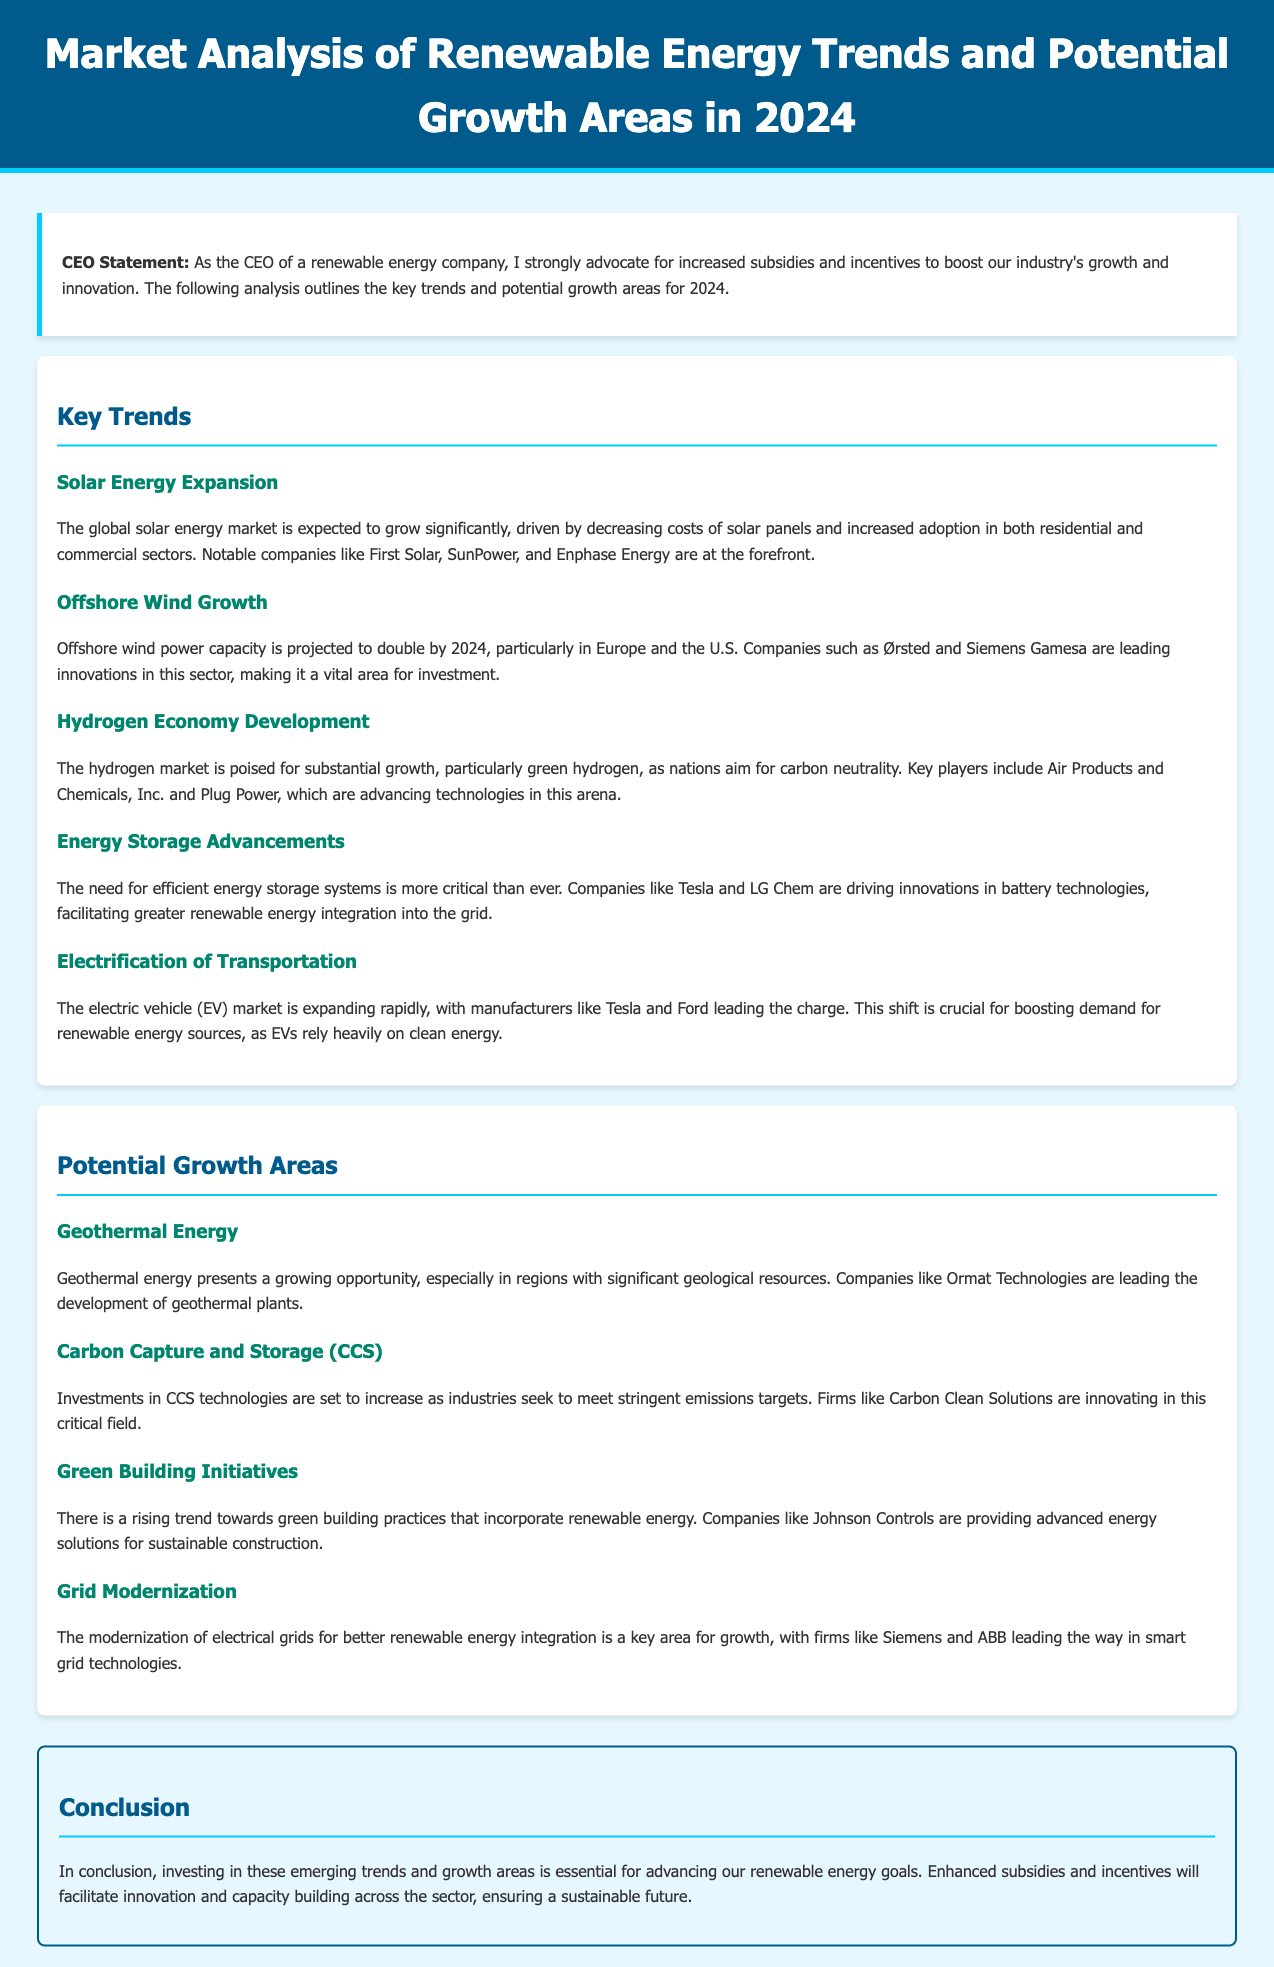What is the projected growth of offshore wind power capacity by 2024? The document states that offshore wind power capacity is projected to double by 2024.
Answer: Double Who are the leading companies in the solar energy sector? The document mentions notable companies like First Solar, SunPower, and Enphase Energy as leaders in solar energy.
Answer: First Solar, SunPower, Enphase Energy What energy source is anticipated to experience substantial growth, particularly in green hydrogen? The document describes the hydrogen market, particularly green hydrogen, as poised for substantial growth.
Answer: Hydrogen What are two key areas expected to grow due to the electrification of transportation? The document highlights that the expansion of the electric vehicle market is crucial for boosting demand for renewable energy sources, which rely heavily on clean energy.
Answer: Electric vehicles, clean energy Which company is leading innovations in carbon capture and storage technologies? The document states that Carbon Clean Solutions is innovating in carbon capture and storage solutions.
Answer: Carbon Clean Solutions What is a growing opportunity that involves significant geological resources? The document identifies geothermal energy as a growing opportunity in regions with significant geological resources.
Answer: Geothermal energy What type of building practices are on the rise incorporating renewable energy? The document refers to green building initiatives as a rising trend in construction practices involving renewable energy.
Answer: Green building initiatives What is identified as critical for better renewable energy integration? The document specifies the modernization of electrical grids as key for better renewable energy integration.
Answer: Grid modernization 